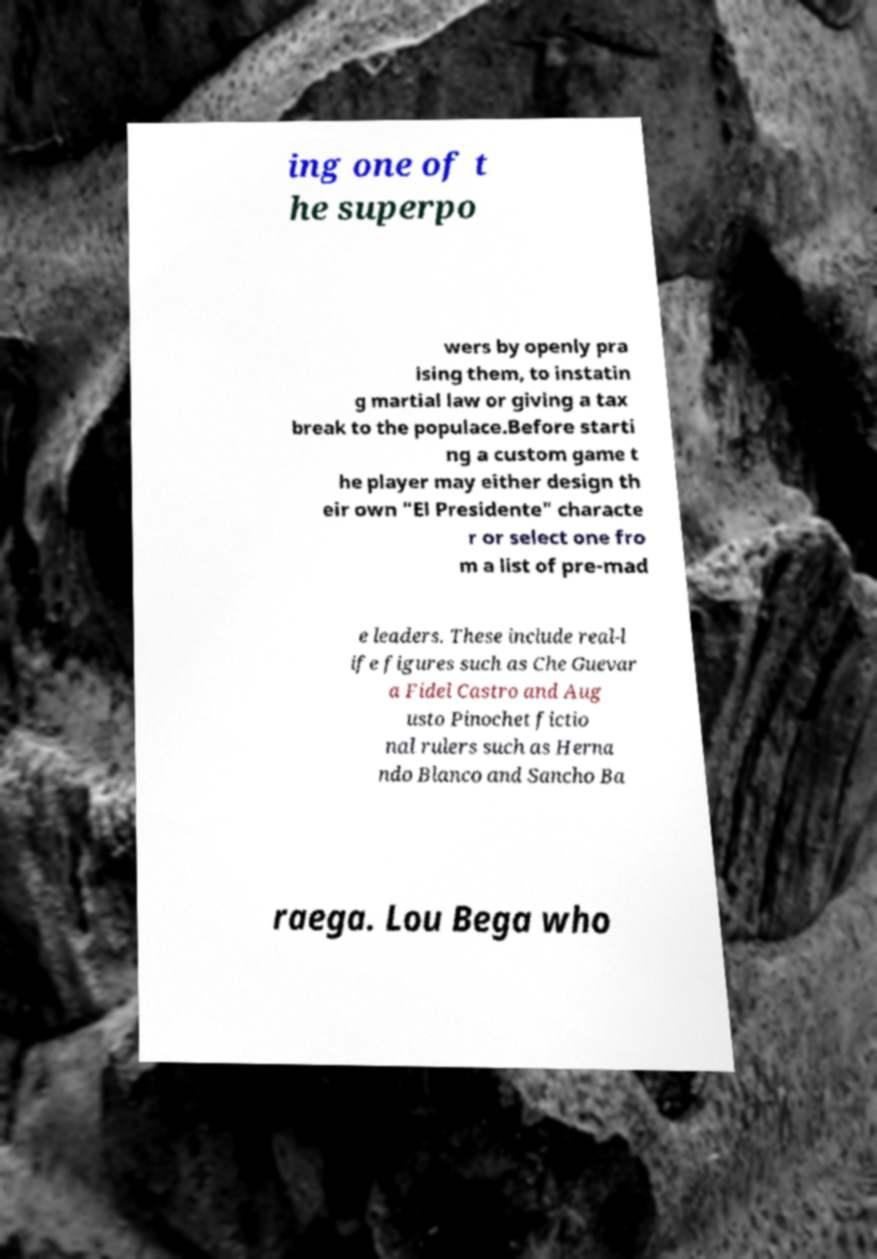Can you read and provide the text displayed in the image?This photo seems to have some interesting text. Can you extract and type it out for me? ing one of t he superpo wers by openly pra ising them, to instatin g martial law or giving a tax break to the populace.Before starti ng a custom game t he player may either design th eir own "El Presidente" characte r or select one fro m a list of pre-mad e leaders. These include real-l ife figures such as Che Guevar a Fidel Castro and Aug usto Pinochet fictio nal rulers such as Herna ndo Blanco and Sancho Ba raega. Lou Bega who 